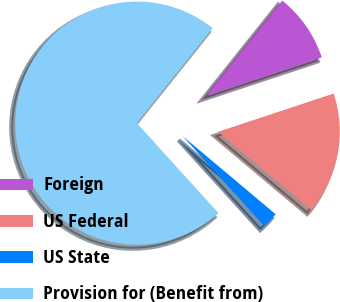Convert chart to OTSL. <chart><loc_0><loc_0><loc_500><loc_500><pie_chart><fcel>Foreign<fcel>US Federal<fcel>US State<fcel>Provision for (Benefit from)<nl><fcel>9.18%<fcel>16.21%<fcel>2.15%<fcel>72.45%<nl></chart> 